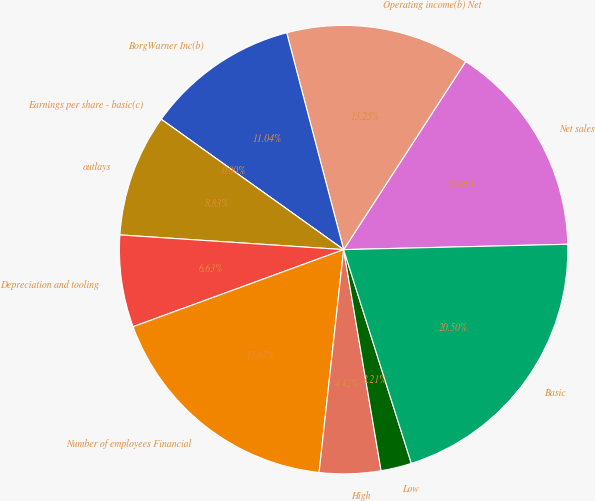Convert chart. <chart><loc_0><loc_0><loc_500><loc_500><pie_chart><fcel>Net sales<fcel>Operating income(b) Net<fcel>BorgWarner Inc(b)<fcel>Earnings per share - basic(c)<fcel>outlays<fcel>Depreciation and tooling<fcel>Number of employees Financial<fcel>High<fcel>Low<fcel>Basic<nl><fcel>15.46%<fcel>13.25%<fcel>11.04%<fcel>0.0%<fcel>8.83%<fcel>6.63%<fcel>17.67%<fcel>4.42%<fcel>2.21%<fcel>20.5%<nl></chart> 